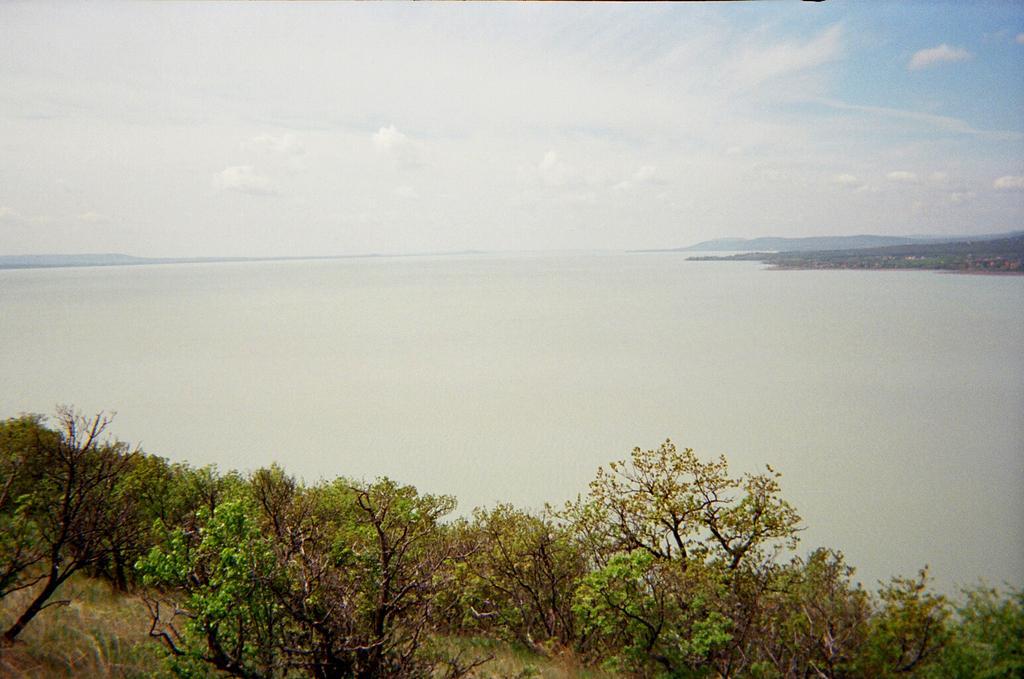Please provide a concise description of this image. In this picture we can see few trees and water, and also we can see clouds. 